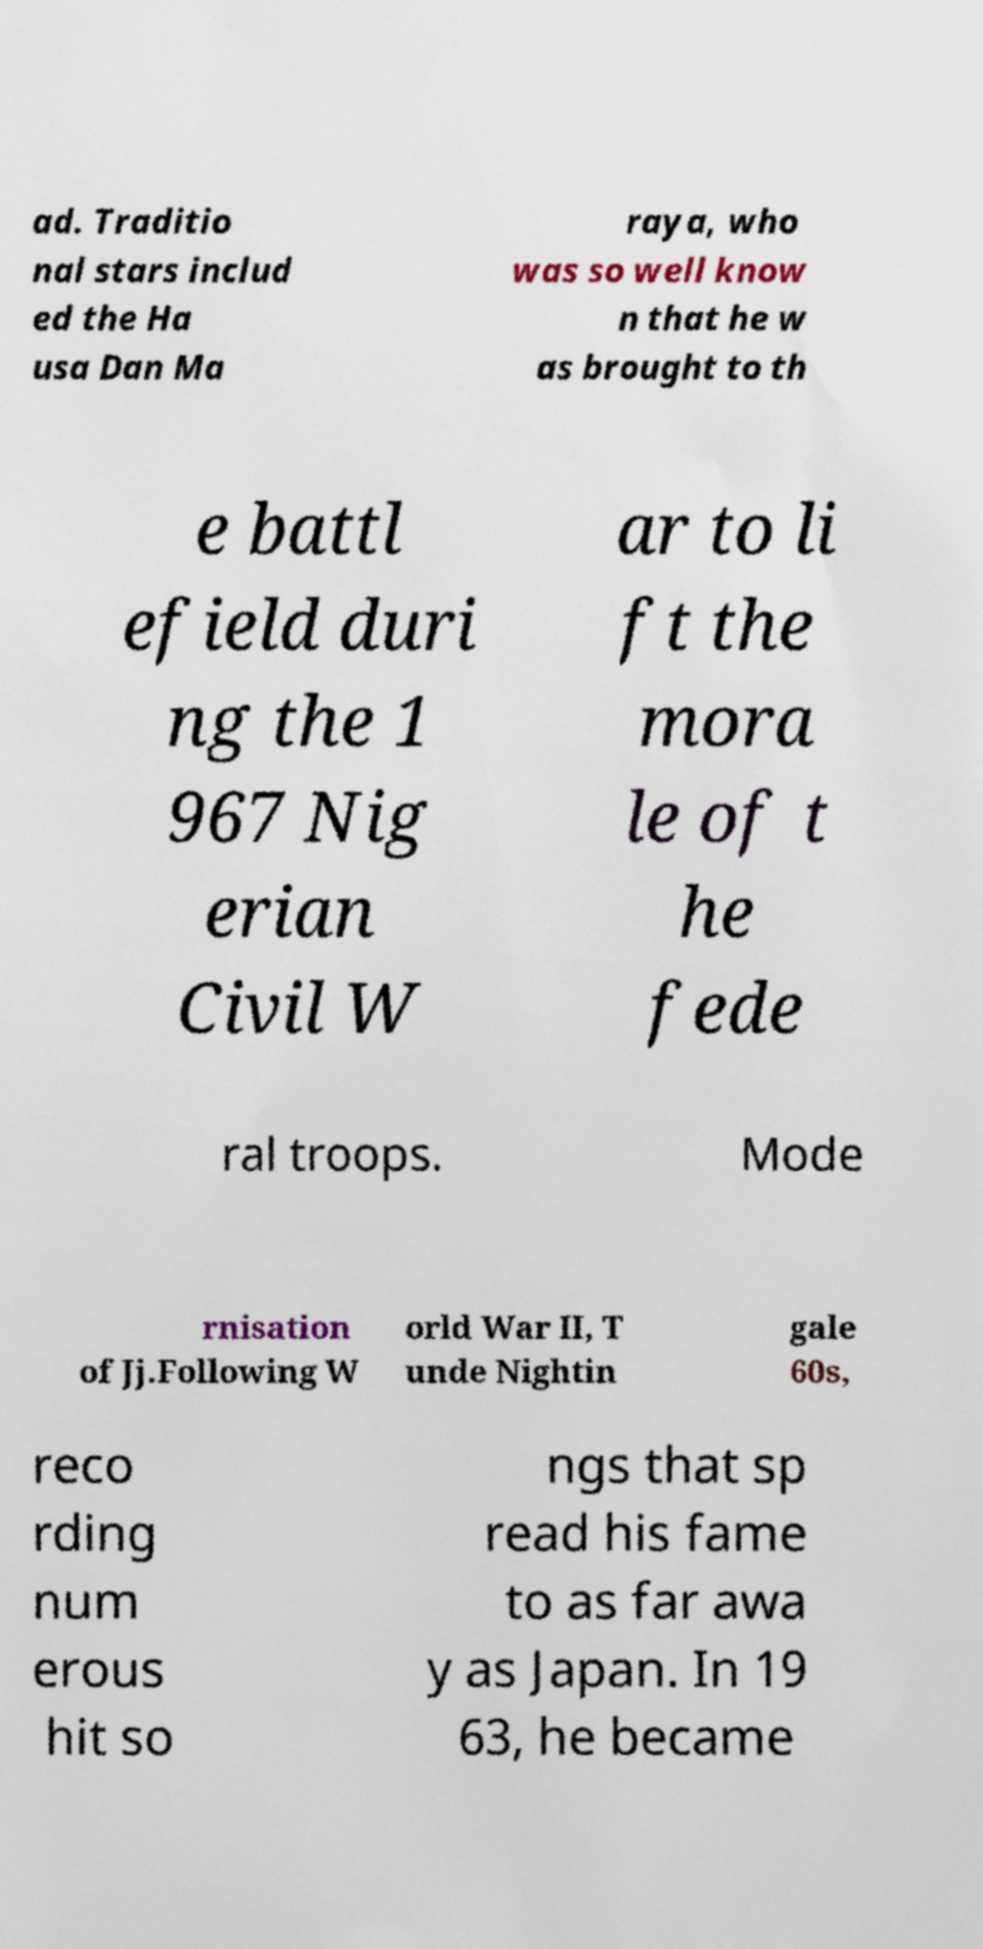Please read and relay the text visible in this image. What does it say? ad. Traditio nal stars includ ed the Ha usa Dan Ma raya, who was so well know n that he w as brought to th e battl efield duri ng the 1 967 Nig erian Civil W ar to li ft the mora le of t he fede ral troops. Mode rnisation of Jj.Following W orld War II, T unde Nightin gale 60s, reco rding num erous hit so ngs that sp read his fame to as far awa y as Japan. In 19 63, he became 